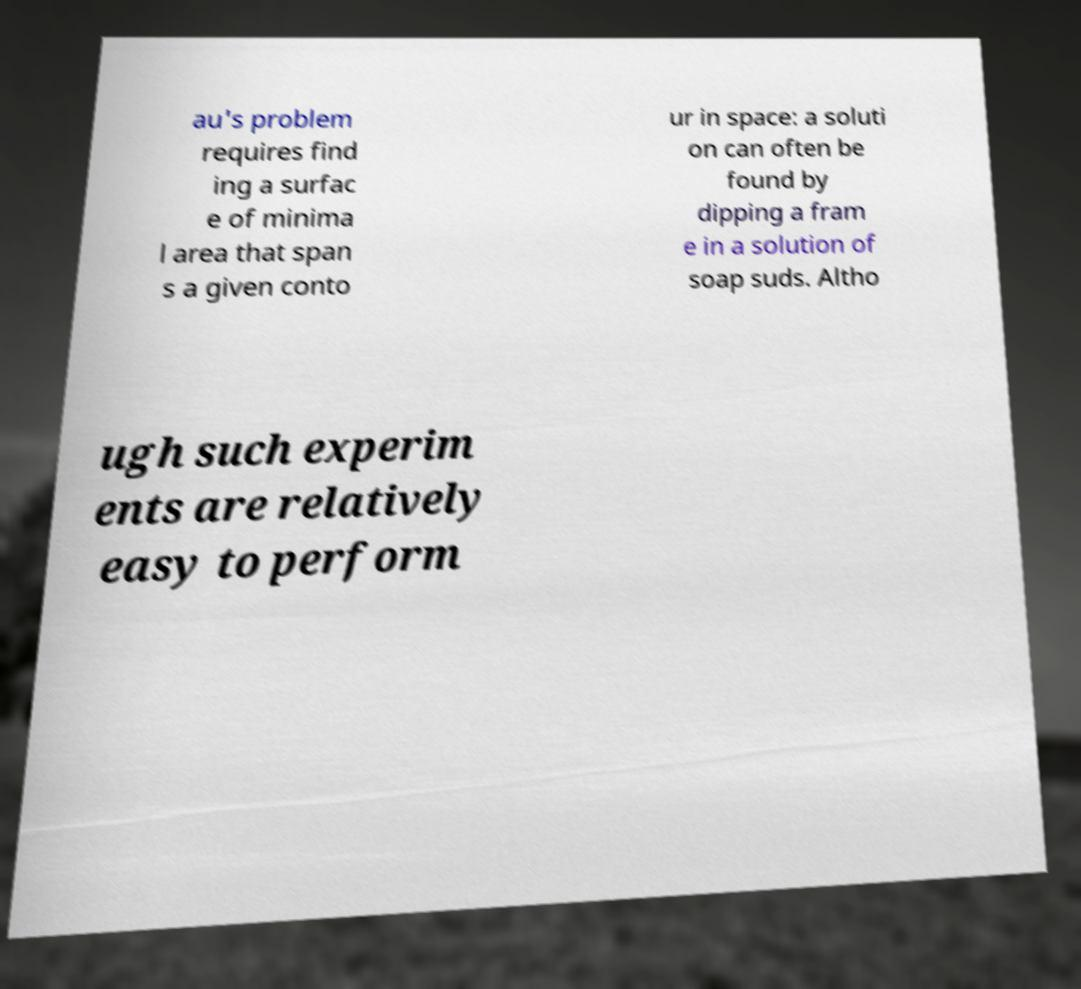Please read and relay the text visible in this image. What does it say? au's problem requires find ing a surfac e of minima l area that span s a given conto ur in space: a soluti on can often be found by dipping a fram e in a solution of soap suds. Altho ugh such experim ents are relatively easy to perform 